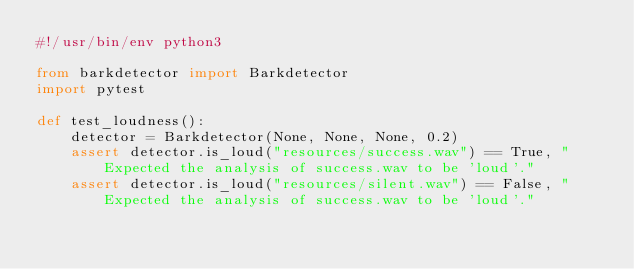Convert code to text. <code><loc_0><loc_0><loc_500><loc_500><_Python_>#!/usr/bin/env python3

from barkdetector import Barkdetector
import pytest

def test_loudness():
    detector = Barkdetector(None, None, None, 0.2)
    assert detector.is_loud("resources/success.wav") == True, "Expected the analysis of success.wav to be 'loud'."
    assert detector.is_loud("resources/silent.wav") == False, "Expected the analysis of success.wav to be 'loud'."
</code> 